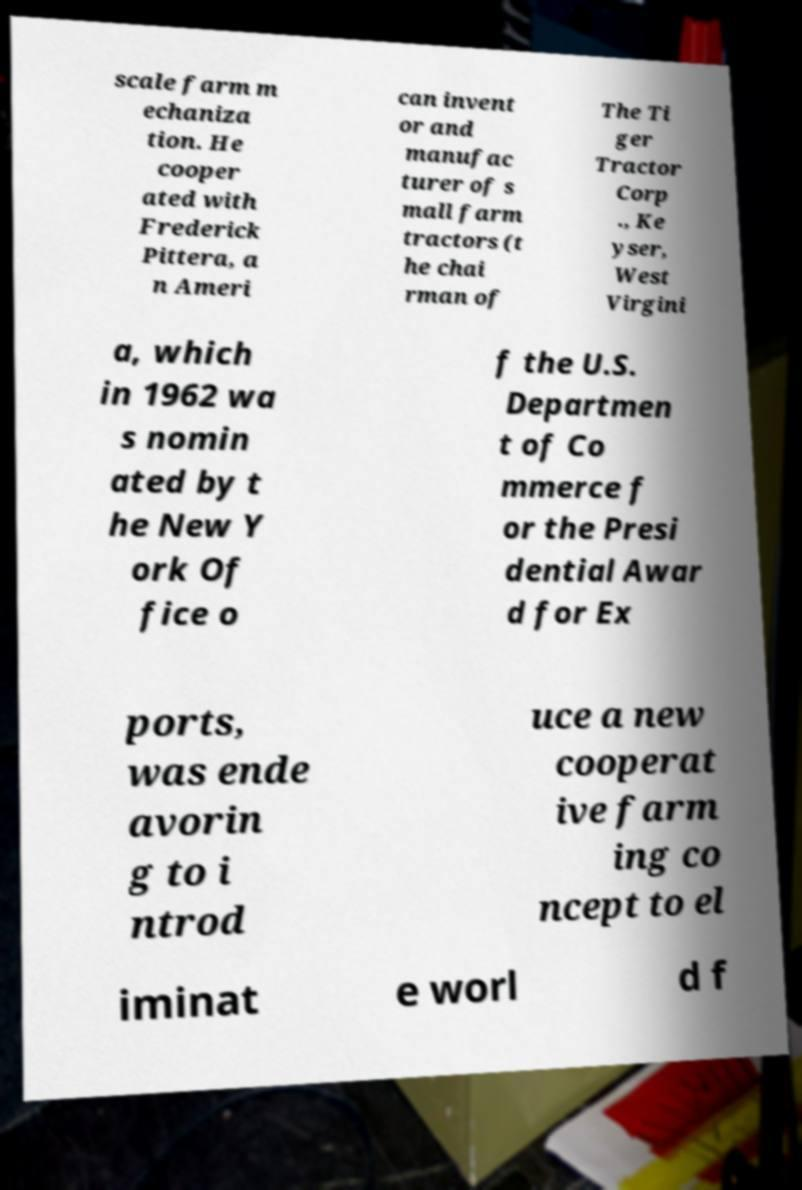Can you accurately transcribe the text from the provided image for me? scale farm m echaniza tion. He cooper ated with Frederick Pittera, a n Ameri can invent or and manufac turer of s mall farm tractors (t he chai rman of The Ti ger Tractor Corp ., Ke yser, West Virgini a, which in 1962 wa s nomin ated by t he New Y ork Of fice o f the U.S. Departmen t of Co mmerce f or the Presi dential Awar d for Ex ports, was ende avorin g to i ntrod uce a new cooperat ive farm ing co ncept to el iminat e worl d f 